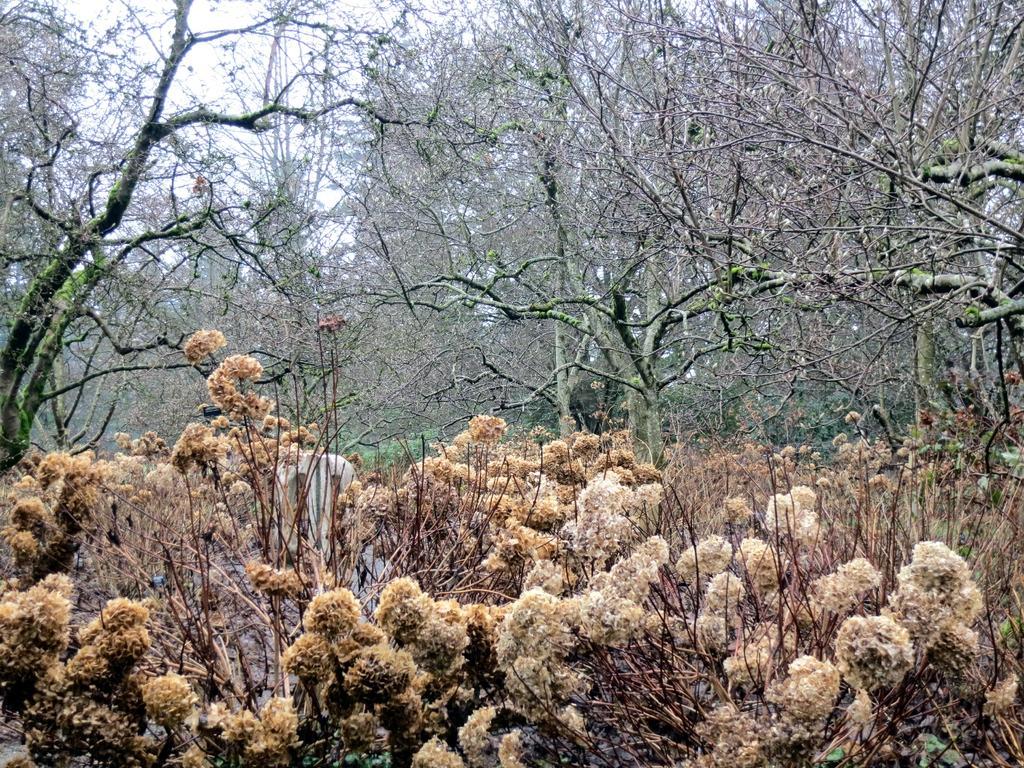In one or two sentences, can you explain what this image depicts? In this image at the bottom there are some plants and flowers, and in the background there are some trees and at the top of the image there is sky. 